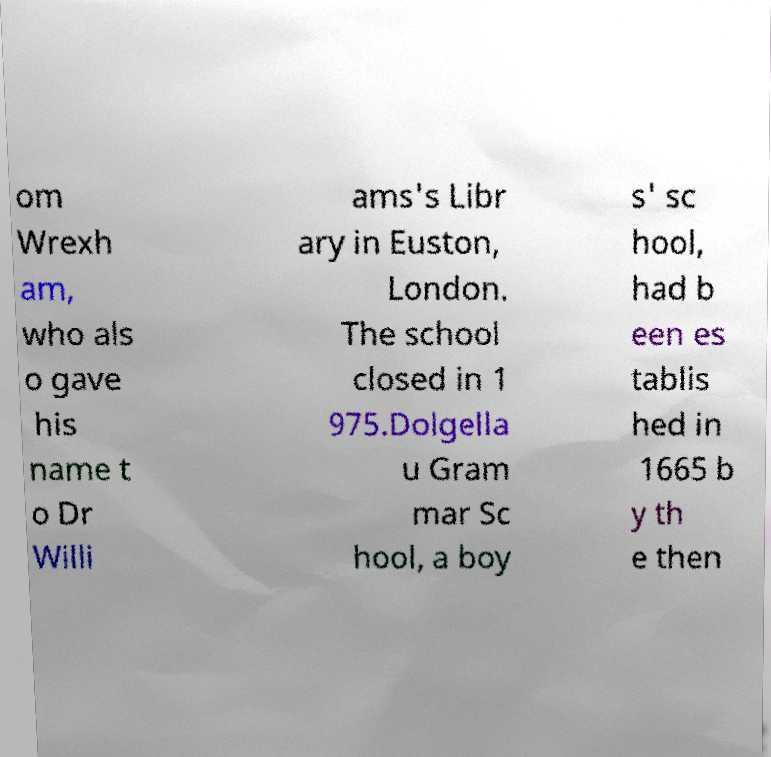Can you read and provide the text displayed in the image?This photo seems to have some interesting text. Can you extract and type it out for me? om Wrexh am, who als o gave his name t o Dr Willi ams's Libr ary in Euston, London. The school closed in 1 975.Dolgella u Gram mar Sc hool, a boy s' sc hool, had b een es tablis hed in 1665 b y th e then 